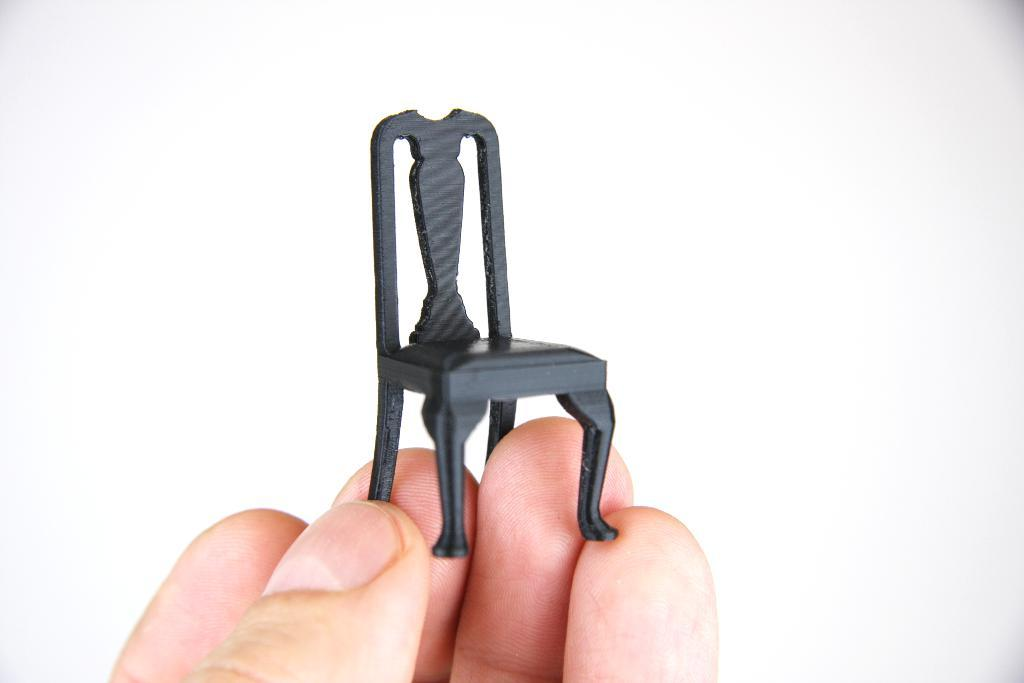What can be seen in the image that belongs to a person? There are fingers of a person in the image. What are the fingers holding? The fingers are holding a miniature art of a chair. What color is the background of the image? The background of the image is white. What type of tramp can be seen jumping in the image? There is no tramp present in the image; it features fingers holding a miniature art of a chair against a white background. How many bags of popcorn are visible in the image? There are no bags of popcorn present in the image. 